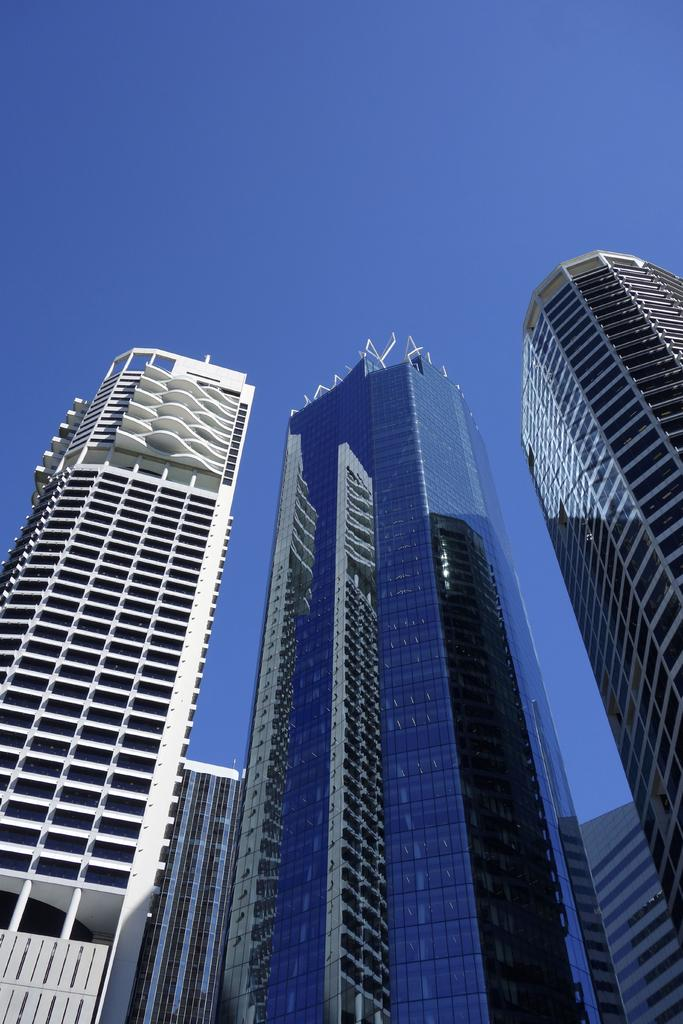What type of structures can be seen in the image? There are buildings in the image. What part of the natural environment is visible in the image? The sky is visible in the image. How many bikes are parked on the edge of the alarm in the image? There are no bikes or alarms present in the image. 